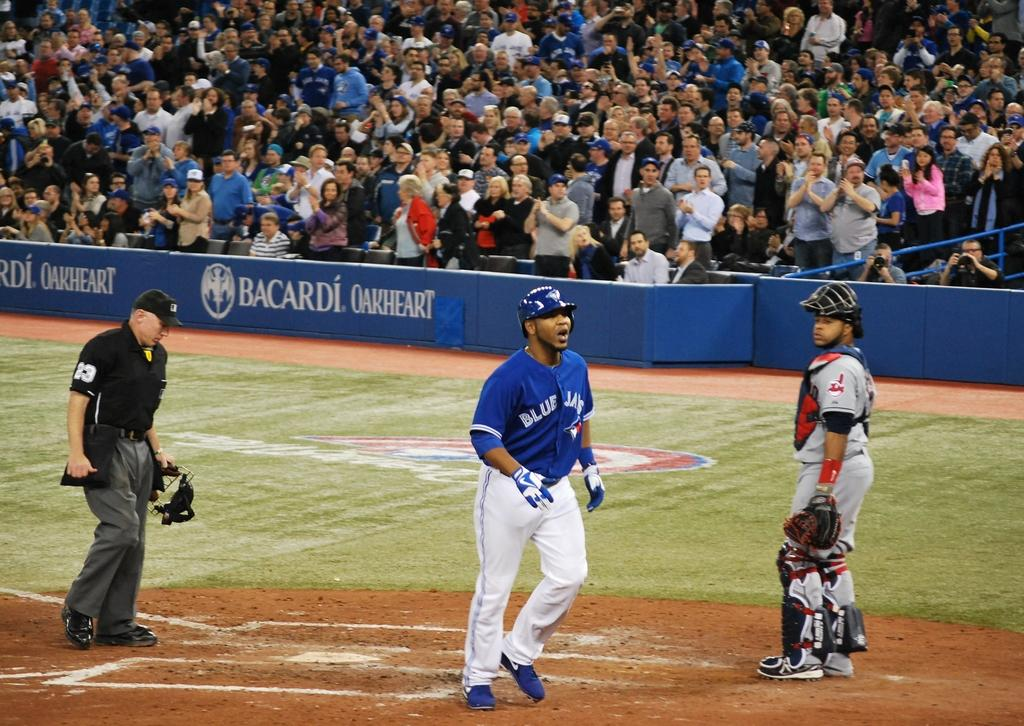<image>
Give a short and clear explanation of the subsequent image. a batter that ha the word blue jays on his jersey 